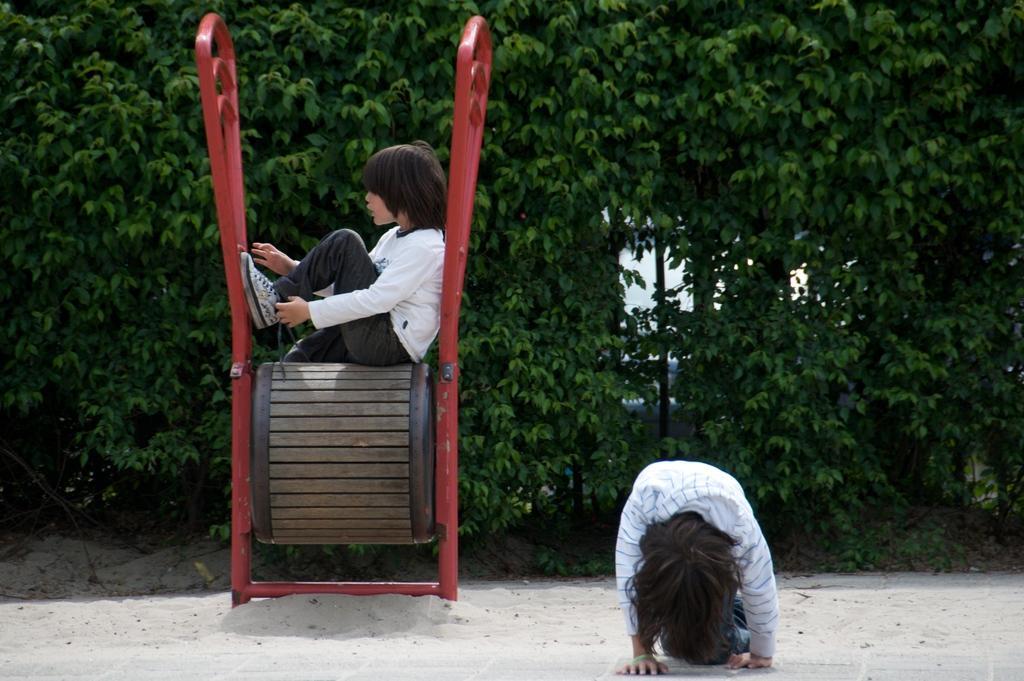Describe this image in one or two sentences. In front of the image there is a person bending. Behind him there is sand on the surface. There is a person sitting on some object. In the background of the image there are trees and a car. 